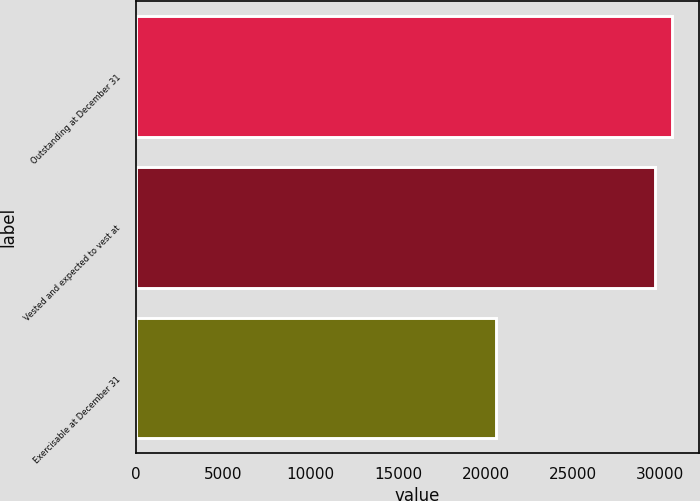Convert chart. <chart><loc_0><loc_0><loc_500><loc_500><bar_chart><fcel>Outstanding at December 31<fcel>Vested and expected to vest at<fcel>Exercisable at December 31<nl><fcel>30654.9<fcel>29686<fcel>20631<nl></chart> 